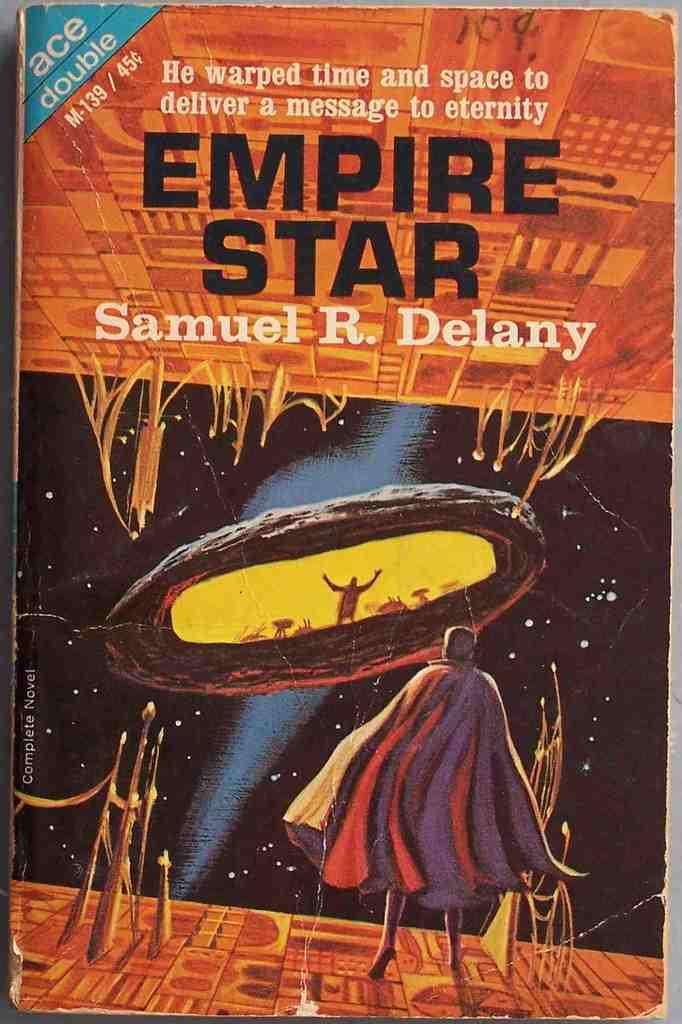Provide a one-sentence caption for the provided image. Ace double is the publisher of Empire Star. 